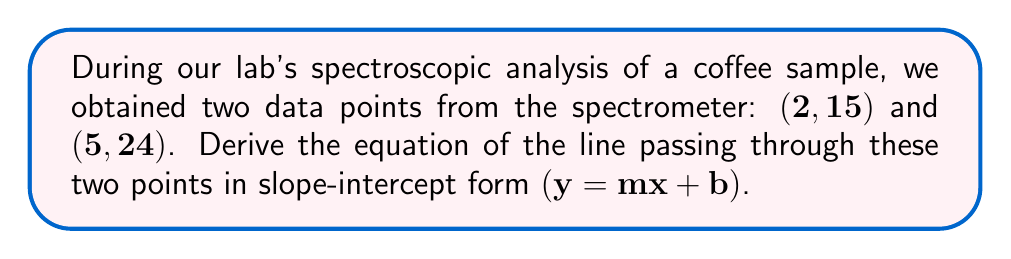Provide a solution to this math problem. Let's approach this step-by-step:

1) To find the equation of a line, we need two things: the slope $(m)$ and the y-intercept $(b)$.

2) First, let's calculate the slope using the slope formula:
   $$m = \frac{y_2 - y_1}{x_2 - x_1}$$

3) Plugging in our points $(2, 15)$ and $(5, 24)$:
   $$m = \frac{24 - 15}{5 - 2} = \frac{9}{3} = 3$$

4) Now that we have the slope, we can use the point-slope form of a line to find $b$:
   $$y - y_1 = m(x - x_1)$$

5) Let's use the point $(2, 15)$. Substituting our known values:
   $$y - 15 = 3(x - 2)$$

6) Distribute the 3:
   $$y - 15 = 3x - 6$$

7) Add 15 to both sides:
   $$y = 3x - 6 + 15$$

8) Simplify:
   $$y = 3x + 9$$

9) This equation is now in slope-intercept form $(y = mx + b)$, where $m = 3$ and $b = 9$.
Answer: $y = 3x + 9$ 